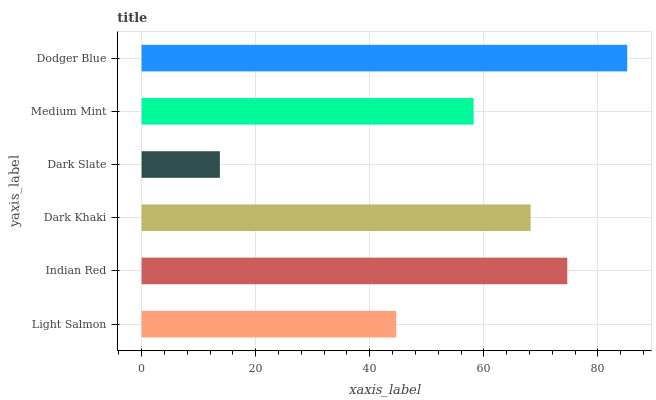Is Dark Slate the minimum?
Answer yes or no. Yes. Is Dodger Blue the maximum?
Answer yes or no. Yes. Is Indian Red the minimum?
Answer yes or no. No. Is Indian Red the maximum?
Answer yes or no. No. Is Indian Red greater than Light Salmon?
Answer yes or no. Yes. Is Light Salmon less than Indian Red?
Answer yes or no. Yes. Is Light Salmon greater than Indian Red?
Answer yes or no. No. Is Indian Red less than Light Salmon?
Answer yes or no. No. Is Dark Khaki the high median?
Answer yes or no. Yes. Is Medium Mint the low median?
Answer yes or no. Yes. Is Medium Mint the high median?
Answer yes or no. No. Is Dark Slate the low median?
Answer yes or no. No. 